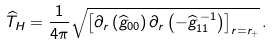Convert formula to latex. <formula><loc_0><loc_0><loc_500><loc_500>\widehat { T } _ { H } = \frac { 1 } { 4 \pi } \sqrt { \left [ \partial _ { r } \left ( \widehat { g } _ { 0 0 } \right ) \partial _ { r } \left ( - \widehat { g } _ { 1 1 } ^ { \, - 1 } \right ) \right ] _ { r = r _ { + } } } \, .</formula> 